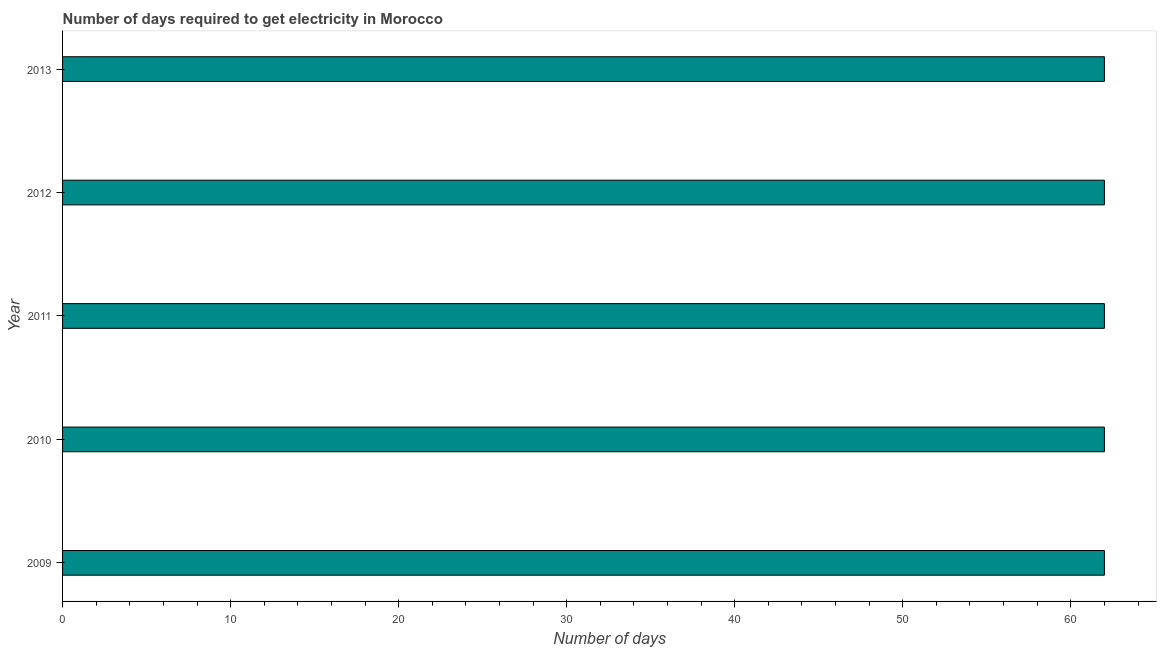Does the graph contain any zero values?
Make the answer very short. No. Does the graph contain grids?
Ensure brevity in your answer.  No. What is the title of the graph?
Keep it short and to the point. Number of days required to get electricity in Morocco. What is the label or title of the X-axis?
Offer a terse response. Number of days. What is the label or title of the Y-axis?
Keep it short and to the point. Year. What is the time to get electricity in 2010?
Provide a short and direct response. 62. What is the sum of the time to get electricity?
Provide a short and direct response. 310. What is the difference between the time to get electricity in 2010 and 2013?
Ensure brevity in your answer.  0. What is the difference between the highest and the second highest time to get electricity?
Your response must be concise. 0. Is the sum of the time to get electricity in 2010 and 2012 greater than the maximum time to get electricity across all years?
Make the answer very short. Yes. What is the difference between two consecutive major ticks on the X-axis?
Your answer should be very brief. 10. Are the values on the major ticks of X-axis written in scientific E-notation?
Your response must be concise. No. What is the Number of days in 2010?
Provide a succinct answer. 62. What is the Number of days in 2012?
Keep it short and to the point. 62. What is the difference between the Number of days in 2009 and 2010?
Provide a short and direct response. 0. What is the difference between the Number of days in 2009 and 2011?
Give a very brief answer. 0. What is the difference between the Number of days in 2009 and 2012?
Your response must be concise. 0. What is the difference between the Number of days in 2010 and 2011?
Ensure brevity in your answer.  0. What is the difference between the Number of days in 2010 and 2013?
Give a very brief answer. 0. What is the difference between the Number of days in 2011 and 2012?
Make the answer very short. 0. What is the difference between the Number of days in 2011 and 2013?
Offer a terse response. 0. What is the difference between the Number of days in 2012 and 2013?
Your answer should be compact. 0. What is the ratio of the Number of days in 2009 to that in 2011?
Your answer should be compact. 1. What is the ratio of the Number of days in 2009 to that in 2012?
Make the answer very short. 1. What is the ratio of the Number of days in 2009 to that in 2013?
Keep it short and to the point. 1. What is the ratio of the Number of days in 2010 to that in 2011?
Provide a short and direct response. 1. What is the ratio of the Number of days in 2010 to that in 2012?
Give a very brief answer. 1. What is the ratio of the Number of days in 2012 to that in 2013?
Give a very brief answer. 1. 